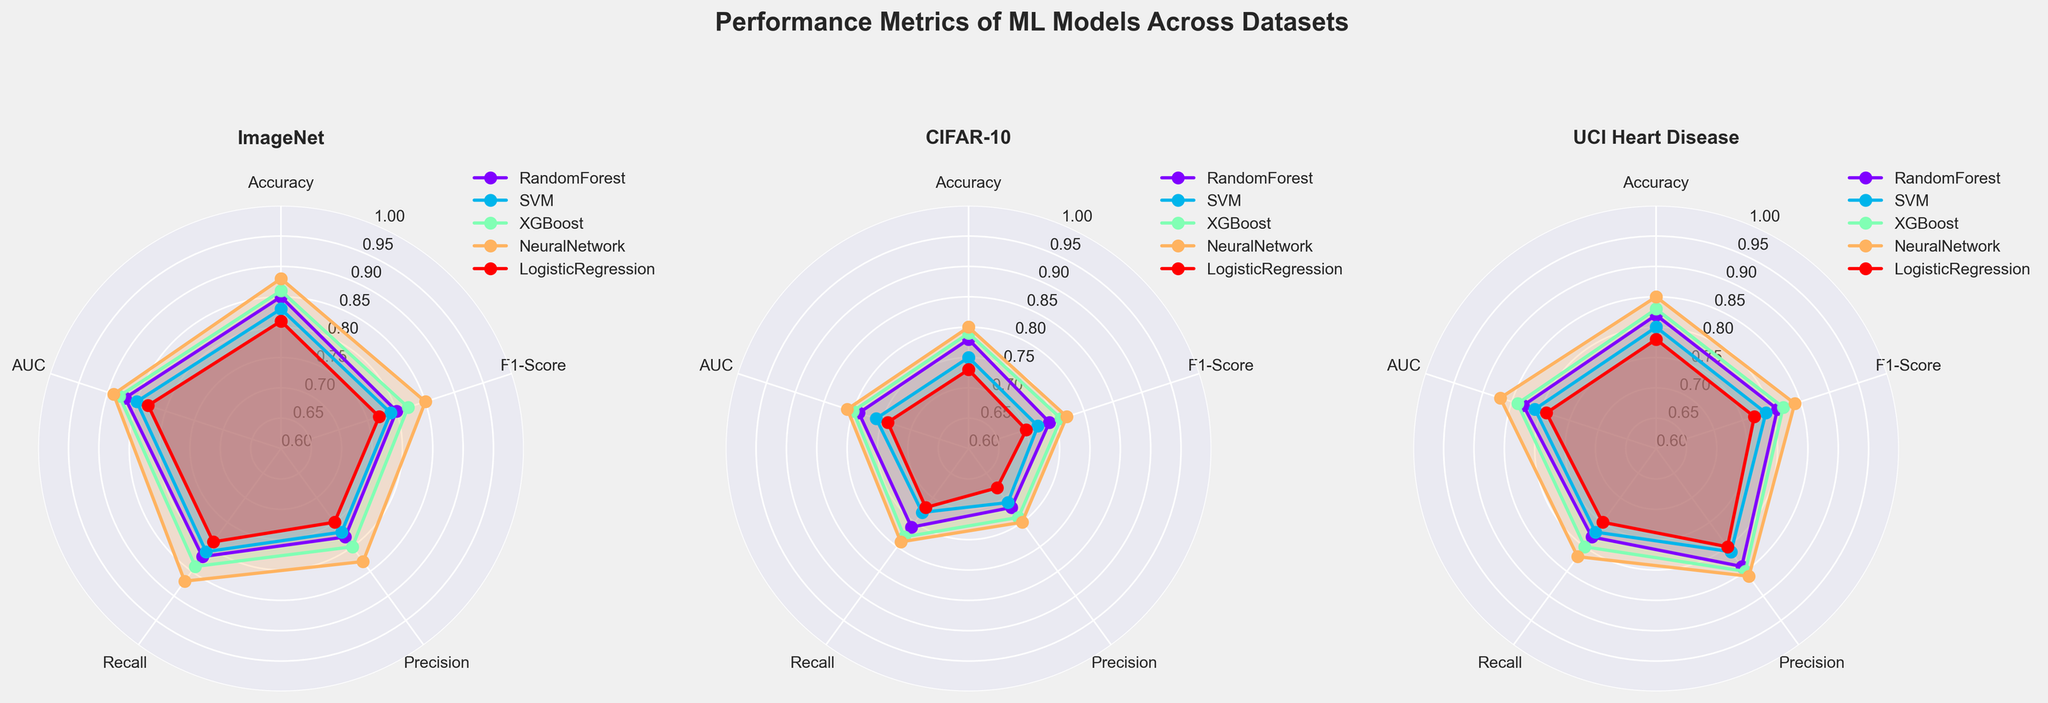What is the title of the figure? The title of the figure is prominently displayed at the top center of the figure. It reads "Performance Metrics of ML Models Across Datasets".
Answer: Performance Metrics of ML Models Across Datasets How many datasets are being compared in the figure? There are three subplots, each labeled with a different dataset name. The datasets are ImageNet, CIFAR-10, and UCI Heart Disease.
Answer: Three Which model has the highest Recall on UCI Heart Disease? By examining the UCI Heart Disease subplot and the value labels on the Recall axis, the NeuralNetwork model shows the highest value in Recall, which is 0.82.
Answer: NeuralNetwork What are the metrics shown on the radial axes? The radial axes are marked with five different performance metrics: Accuracy, F1-Score, Precision, Recall, and AUC.
Answer: Accuracy, F1-Score, Precision, Recall, AUC Which model shows the best overall performance on ImageNet based on the filled areas? On the ImageNet subplot, the model with the largest filled area (indicating stronger performance across all metrics) is the NeuralNetwork.
Answer: NeuralNetwork Which dataset shows the most variation in Precision between models? By inspecting each subplot, the CIFAR-10 dataset shows the most variation in the Precision metric, where the values of the models differ substantially.
Answer: CIFAR-10 Comparing RandomForest and SVM on CIFAR-10, which has a higher F1-Score? On the CIFAR-10 subplot, compare the positions of the RandomForest and SVM lines on the F1-Score axis. RandomForest has a higher F1-Score at 0.74 compared to SVM’s 0.72.
Answer: RandomForest Summing up the AUC values for XGBoost on all datasets, what is the total? By summing the AUC values of XGBoost from the three subplots: ImageNet (0.88), CIFAR-10 (0.80), and UCI Heart Disease (0.84), we get 0.88 + 0.80 + 0.84 = 2.52.
Answer: 2.52 Which model has the least variation in performance metrics on UCI Heart Disease? On the UCI Heart Disease subplot, the Logistic Regression model shows the smallest filled area, indicating the least variation in its performance metrics across Accuracy, F1-Score, Precision, Recall, and AUC.
Answer: LogisticRegression List the performance metrics where NeuralNetwork outperforms all other models on CIFAR-10. On the CIFAR-10 subplot, marking points for each metric, NeuralNetwork outperforms all others in Accuracy, F1-Score, Precision, Recall, and AUC. Specifically, NeuralNetwork has the highest values in all five metrics compared to others.
Answer: Accuracy, F1-Score, Precision, Recall, AUC 